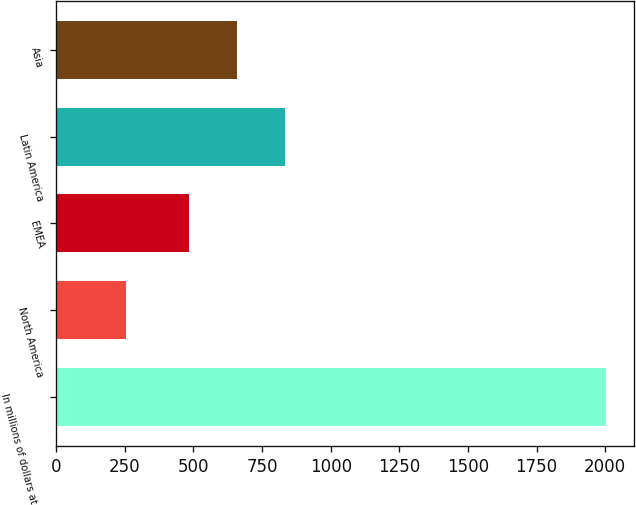Convert chart to OTSL. <chart><loc_0><loc_0><loc_500><loc_500><bar_chart><fcel>In millions of dollars at year<fcel>North America<fcel>EMEA<fcel>Latin America<fcel>Asia<nl><fcel>2004<fcel>253<fcel>482<fcel>832.2<fcel>657.1<nl></chart> 